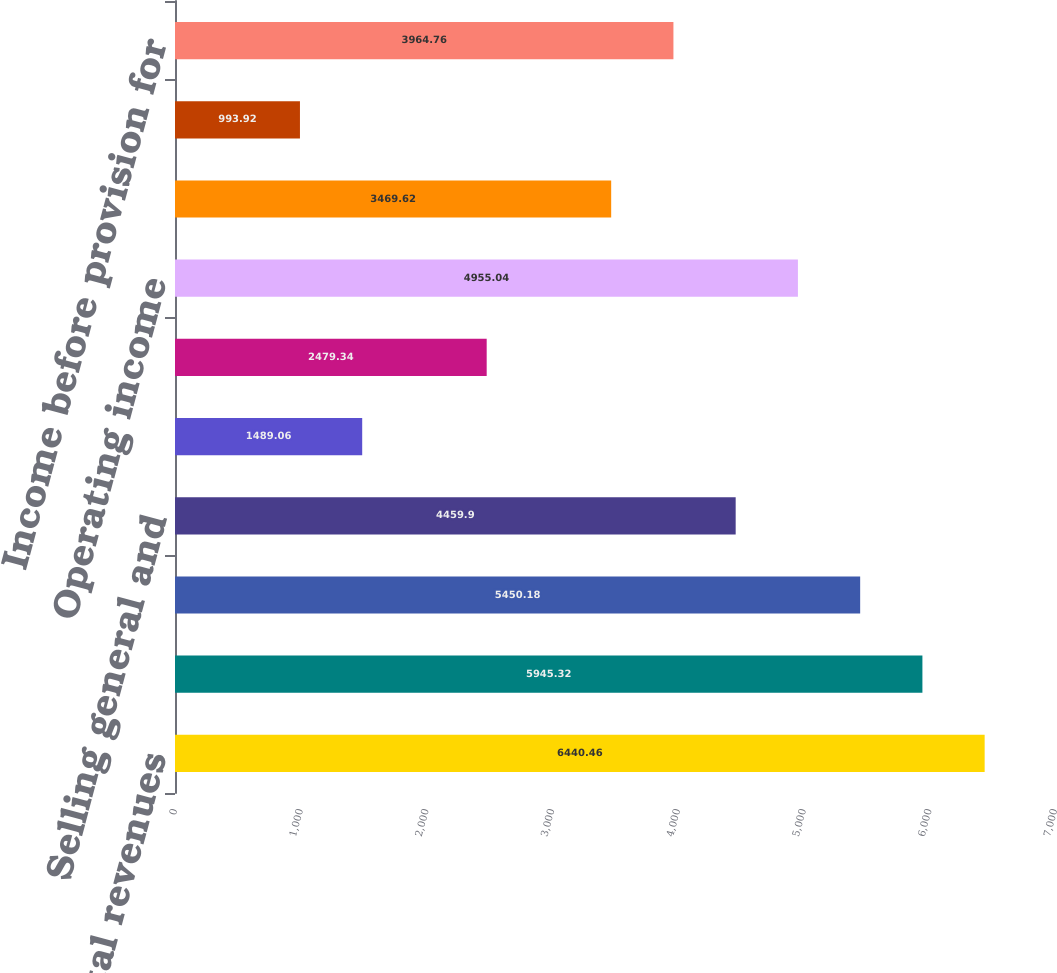Convert chart. <chart><loc_0><loc_0><loc_500><loc_500><bar_chart><fcel>Total revenues<fcel>Total cost of revenues<fcel>Gross profit<fcel>Selling general and<fcel>Restructuring charge<fcel>Non-rental depreciation and<fcel>Operating income<fcel>Interest expense net<fcel>Other income net<fcel>Income before provision for<nl><fcel>6440.46<fcel>5945.32<fcel>5450.18<fcel>4459.9<fcel>1489.06<fcel>2479.34<fcel>4955.04<fcel>3469.62<fcel>993.92<fcel>3964.76<nl></chart> 